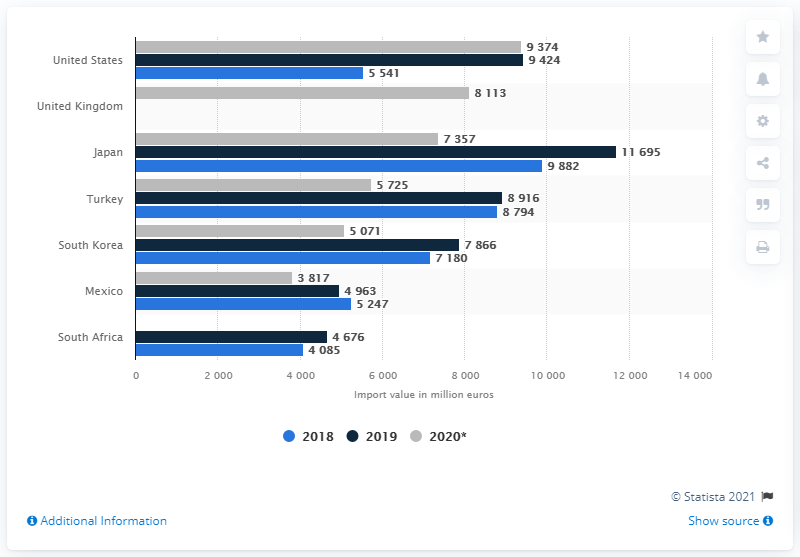Highlight a few significant elements in this photo. In the first 11 months of 2020, the value of passenger cars imported from the United States was 9,424. 